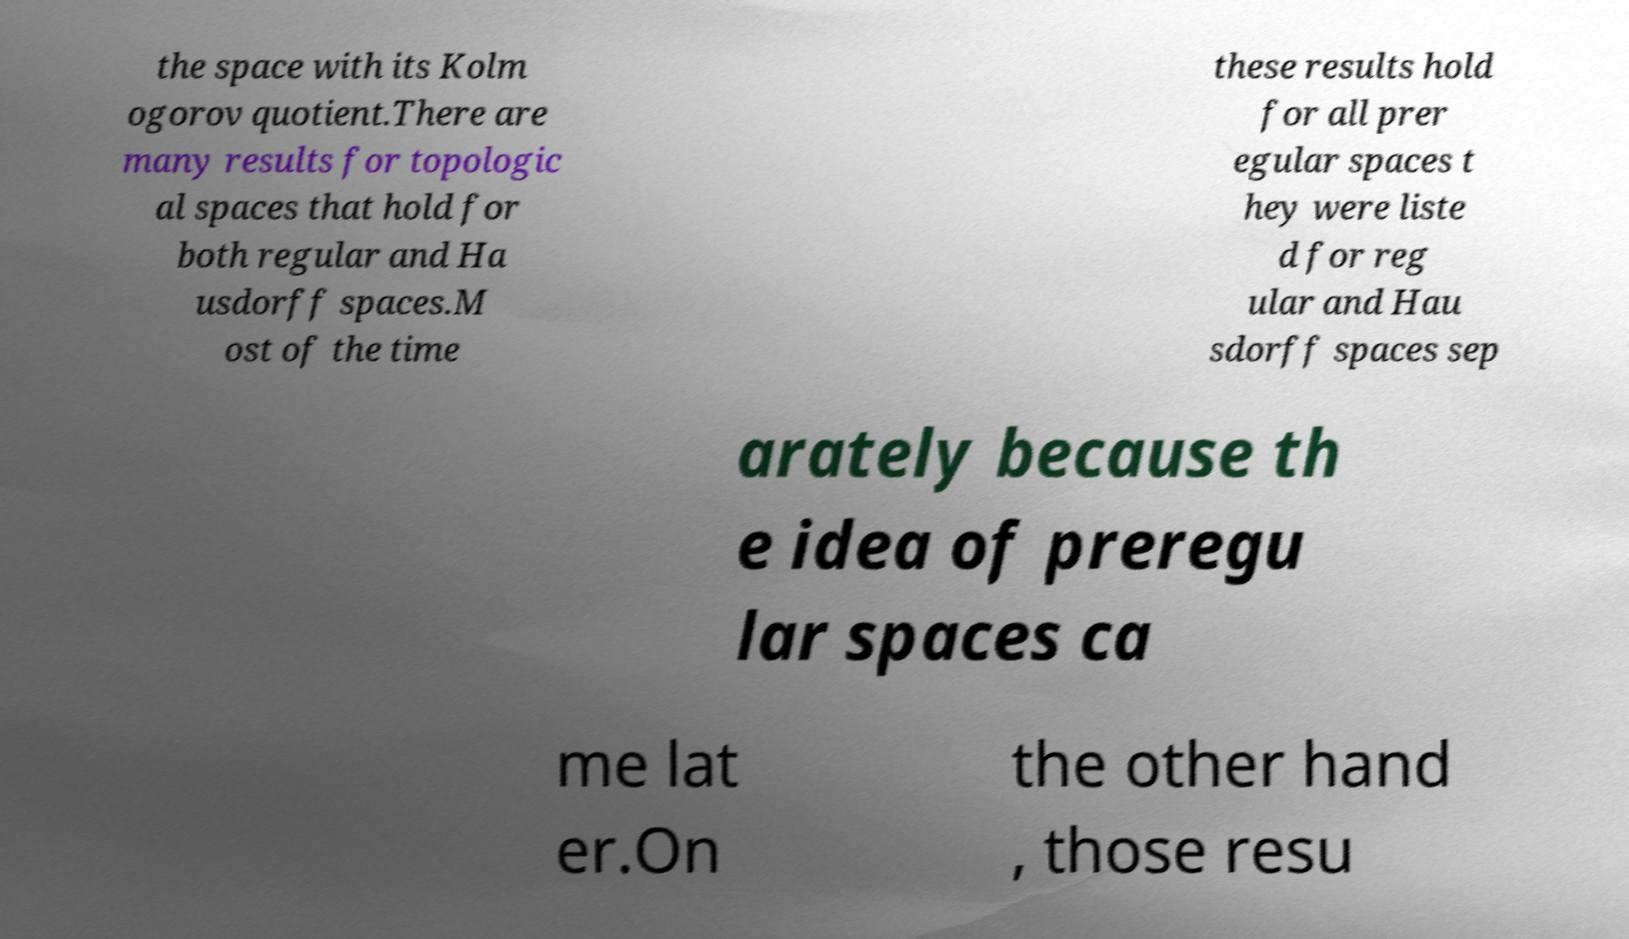I need the written content from this picture converted into text. Can you do that? the space with its Kolm ogorov quotient.There are many results for topologic al spaces that hold for both regular and Ha usdorff spaces.M ost of the time these results hold for all prer egular spaces t hey were liste d for reg ular and Hau sdorff spaces sep arately because th e idea of preregu lar spaces ca me lat er.On the other hand , those resu 